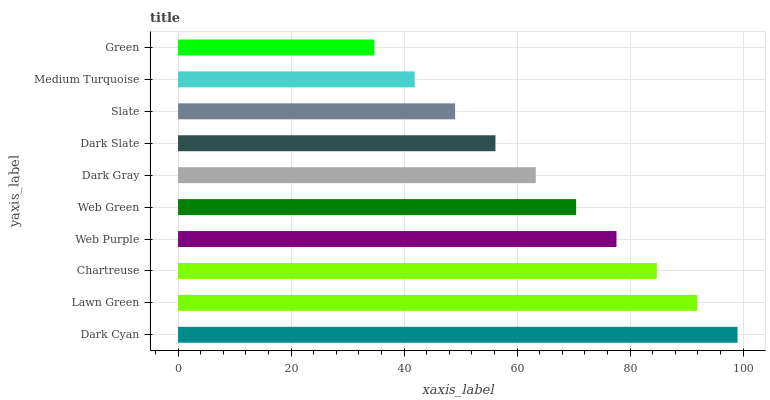Is Green the minimum?
Answer yes or no. Yes. Is Dark Cyan the maximum?
Answer yes or no. Yes. Is Lawn Green the minimum?
Answer yes or no. No. Is Lawn Green the maximum?
Answer yes or no. No. Is Dark Cyan greater than Lawn Green?
Answer yes or no. Yes. Is Lawn Green less than Dark Cyan?
Answer yes or no. Yes. Is Lawn Green greater than Dark Cyan?
Answer yes or no. No. Is Dark Cyan less than Lawn Green?
Answer yes or no. No. Is Web Green the high median?
Answer yes or no. Yes. Is Dark Gray the low median?
Answer yes or no. Yes. Is Dark Slate the high median?
Answer yes or no. No. Is Web Green the low median?
Answer yes or no. No. 